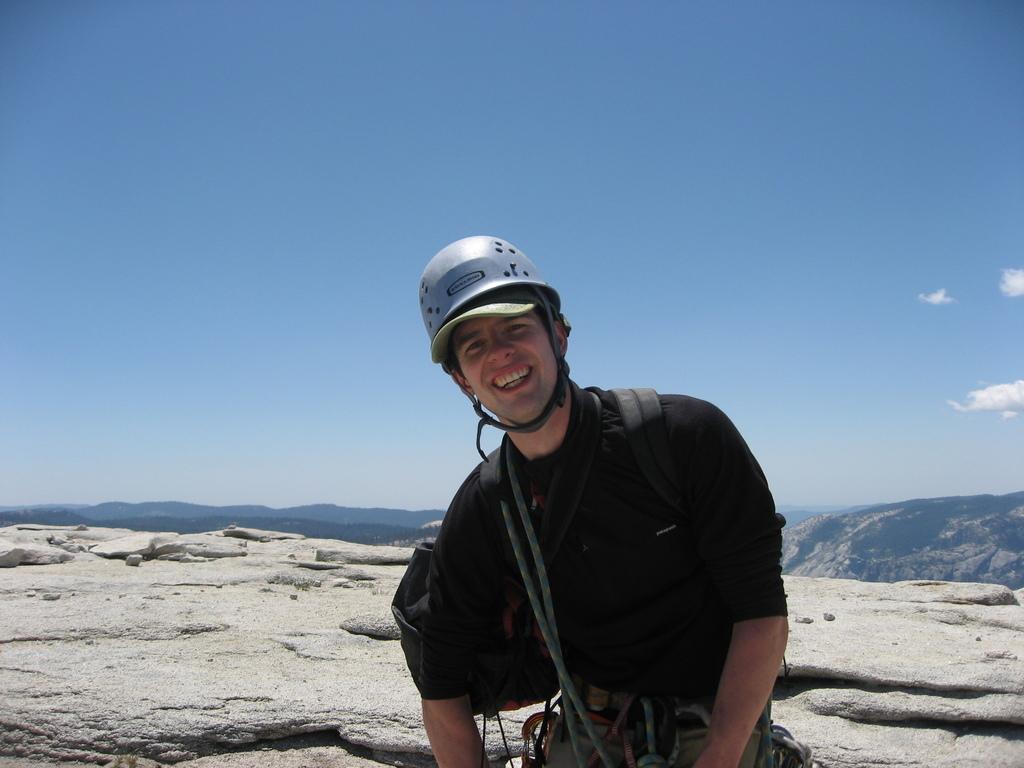In one or two sentences, can you explain what this image depicts? In the picture I can see a person wearing black color T-shirt, also wearing helmet carrying bag standing on mountain and in the background there are some mountains and clear sky. 